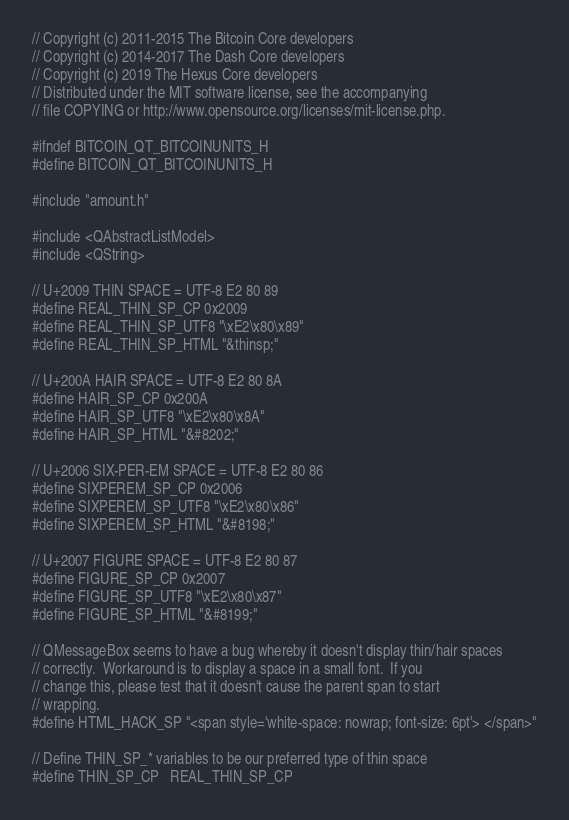Convert code to text. <code><loc_0><loc_0><loc_500><loc_500><_C_>// Copyright (c) 2011-2015 The Bitcoin Core developers
// Copyright (c) 2014-2017 The Dash Core developers
// Copyright (c) 2019 The Hexus Core developers
// Distributed under the MIT software license, see the accompanying
// file COPYING or http://www.opensource.org/licenses/mit-license.php.

#ifndef BITCOIN_QT_BITCOINUNITS_H
#define BITCOIN_QT_BITCOINUNITS_H

#include "amount.h"

#include <QAbstractListModel>
#include <QString>

// U+2009 THIN SPACE = UTF-8 E2 80 89
#define REAL_THIN_SP_CP 0x2009
#define REAL_THIN_SP_UTF8 "\xE2\x80\x89"
#define REAL_THIN_SP_HTML "&thinsp;"

// U+200A HAIR SPACE = UTF-8 E2 80 8A
#define HAIR_SP_CP 0x200A
#define HAIR_SP_UTF8 "\xE2\x80\x8A"
#define HAIR_SP_HTML "&#8202;"

// U+2006 SIX-PER-EM SPACE = UTF-8 E2 80 86
#define SIXPEREM_SP_CP 0x2006
#define SIXPEREM_SP_UTF8 "\xE2\x80\x86"
#define SIXPEREM_SP_HTML "&#8198;"

// U+2007 FIGURE SPACE = UTF-8 E2 80 87
#define FIGURE_SP_CP 0x2007
#define FIGURE_SP_UTF8 "\xE2\x80\x87"
#define FIGURE_SP_HTML "&#8199;"

// QMessageBox seems to have a bug whereby it doesn't display thin/hair spaces
// correctly.  Workaround is to display a space in a small font.  If you
// change this, please test that it doesn't cause the parent span to start
// wrapping.
#define HTML_HACK_SP "<span style='white-space: nowrap; font-size: 6pt'> </span>"

// Define THIN_SP_* variables to be our preferred type of thin space
#define THIN_SP_CP   REAL_THIN_SP_CP</code> 